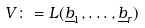<formula> <loc_0><loc_0><loc_500><loc_500>V \colon = L ( \underline { b } _ { 1 } , \dots , \underline { b } _ { r } )</formula> 